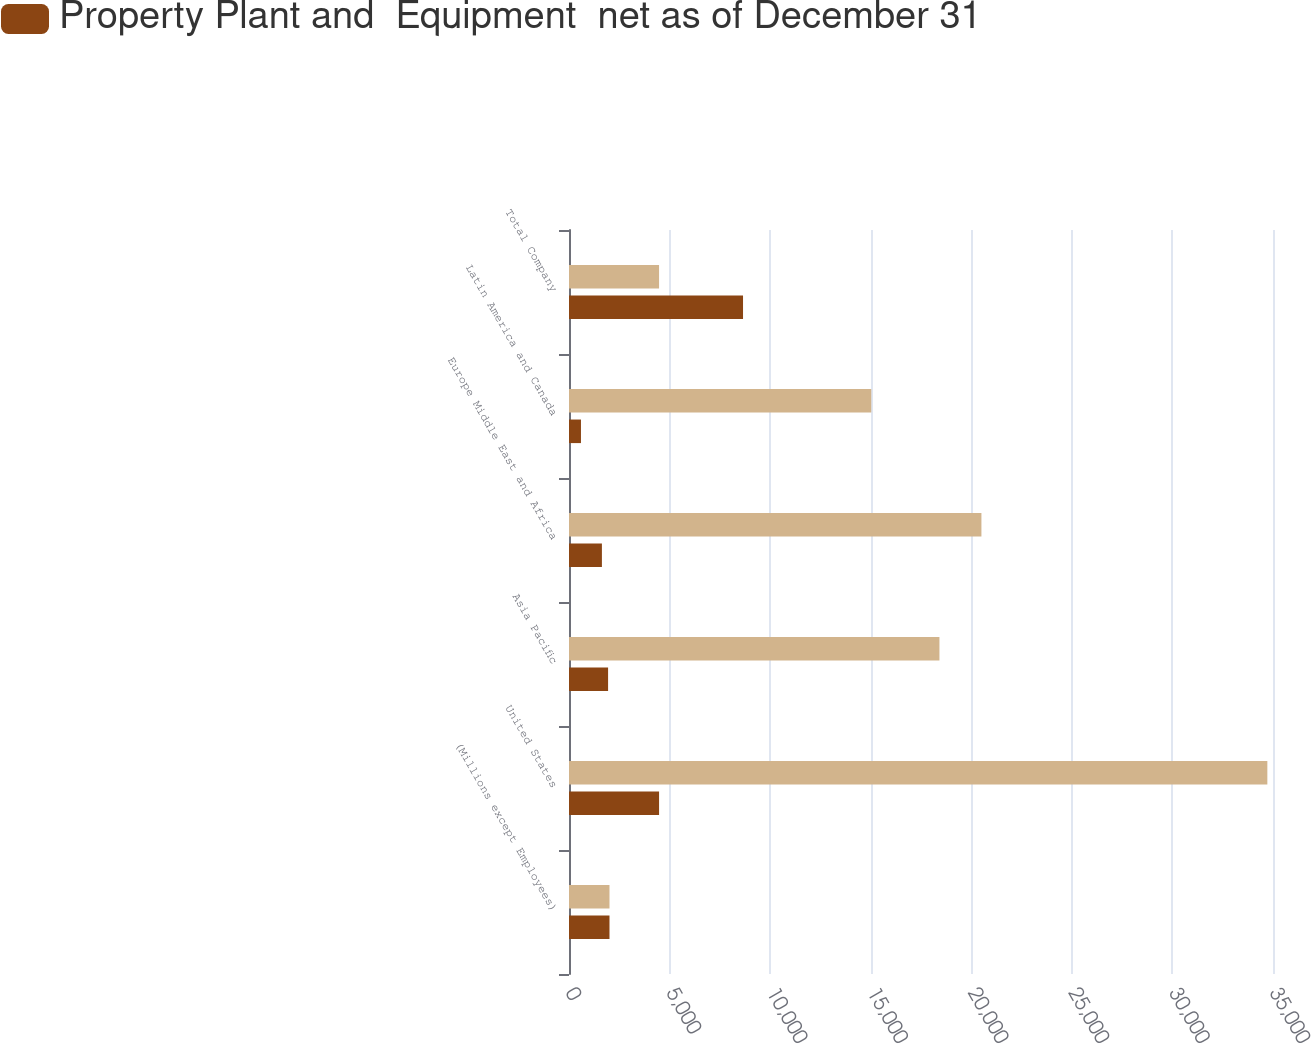<chart> <loc_0><loc_0><loc_500><loc_500><stacked_bar_chart><ecel><fcel>(Millions except Employees)<fcel>United States<fcel>Asia Pacific<fcel>Europe Middle East and Africa<fcel>Latin America and Canada<fcel>Total Company<nl><fcel>nan<fcel>2013<fcel>34719<fcel>18417<fcel>20504<fcel>15027<fcel>4478<nl><fcel>Property Plant and  Equipment  net as of December 31<fcel>2013<fcel>4478<fcel>1943<fcel>1636<fcel>595<fcel>8652<nl></chart> 